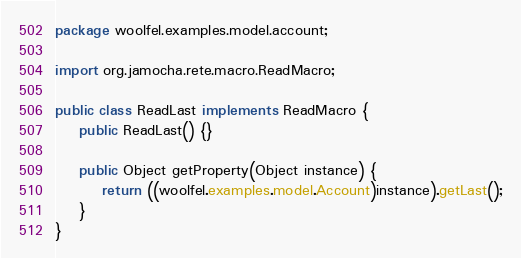Convert code to text. <code><loc_0><loc_0><loc_500><loc_500><_Java_>package woolfel.examples.model.account;

import org.jamocha.rete.macro.ReadMacro;

public class ReadLast implements ReadMacro {
    public ReadLast() {}

    public Object getProperty(Object instance) {
        return ((woolfel.examples.model.Account)instance).getLast();
    }
}
</code> 